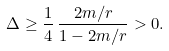Convert formula to latex. <formula><loc_0><loc_0><loc_500><loc_500>\Delta \geq \frac { 1 } { 4 } \, \frac { 2 m / r } { 1 - 2 m / r } > 0 .</formula> 